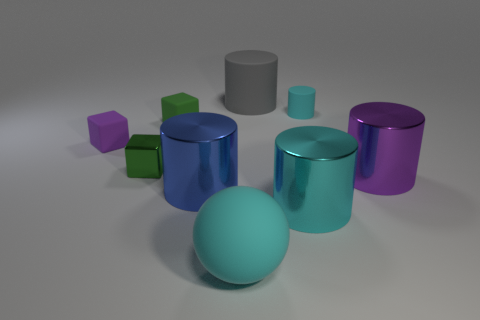Can you tell me the different textures or materials that are represented by the objects and how you can distinguish them? Certainly. In the image, there seem to be objects with at least two different types of textures or materials. One type has a shiny, reflective surface which suggests a metallic material; this is seen in the purple and teal cylinders and the blue cube. The other type has a matte finish, which indicates a rubbery or plastic material; this is observed in the green cubes, the gray sphere, and the gray cylinder. You can distinguish these materials by the way light reflects off of them: the metallic objects have sharper highlights and crisper reflections, while the matte objects scatter light more diffusely. 